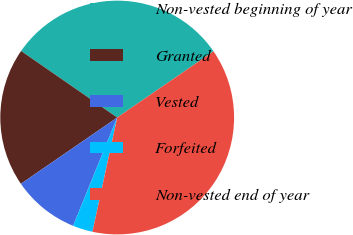<chart> <loc_0><loc_0><loc_500><loc_500><pie_chart><fcel>Non-vested beginning of year<fcel>Granted<fcel>Vested<fcel>Forfeited<fcel>Non-vested end of year<nl><fcel>30.77%<fcel>19.23%<fcel>9.25%<fcel>2.76%<fcel>37.98%<nl></chart> 